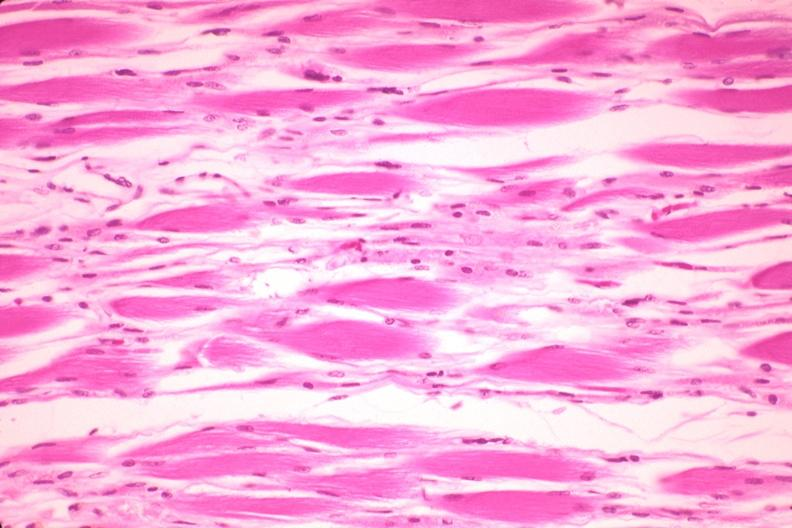s soft tissue present?
Answer the question using a single word or phrase. Yes 